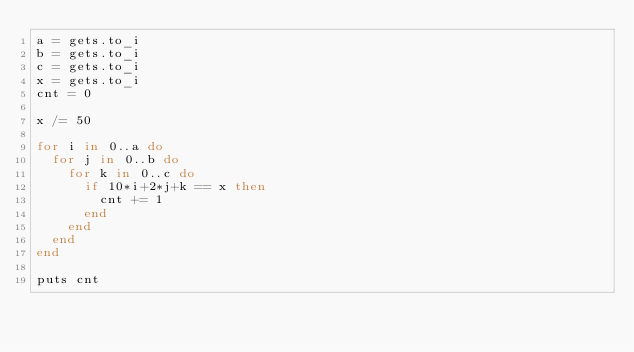<code> <loc_0><loc_0><loc_500><loc_500><_Ruby_>a = gets.to_i
b = gets.to_i
c = gets.to_i
x = gets.to_i
cnt = 0

x /= 50

for i in 0..a do
  for j in 0..b do
    for k in 0..c do
      if 10*i+2*j+k == x then
        cnt += 1
      end
    end
  end
end

puts cnt
</code> 